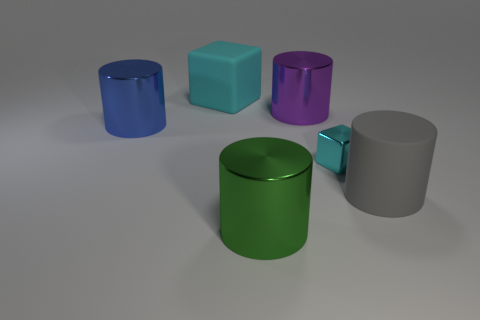There is a rubber object on the left side of the purple cylinder; does it have the same size as the metallic object to the right of the purple metal object?
Keep it short and to the point. No. What number of things are either things that are right of the big cyan object or big things that are on the right side of the cyan rubber thing?
Ensure brevity in your answer.  4. Is the material of the large green cylinder the same as the cylinder on the left side of the green metallic cylinder?
Provide a succinct answer. Yes. There is a big thing that is right of the green object and behind the cyan metallic object; what is its shape?
Ensure brevity in your answer.  Cylinder. What number of other objects are there of the same color as the matte cylinder?
Provide a short and direct response. 0. The green shiny object is what shape?
Offer a very short reply. Cylinder. The big cylinder that is in front of the large rubber thing to the right of the big green metal cylinder is what color?
Ensure brevity in your answer.  Green. There is a tiny object; does it have the same color as the large matte object that is on the left side of the metallic cube?
Keep it short and to the point. Yes. There is a object that is in front of the big purple metallic object and behind the cyan metal thing; what is its material?
Offer a terse response. Metal. Is there a blue shiny object that has the same size as the green metallic cylinder?
Your answer should be very brief. Yes. 